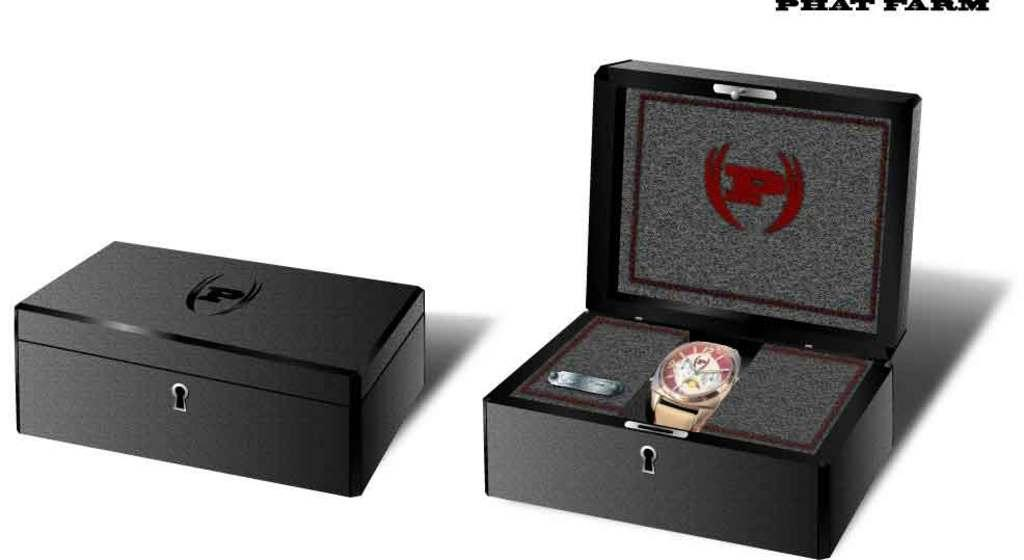Provide a one-sentence caption for the provided image. Two boxes with the letter p and one box open with a watch inside. 